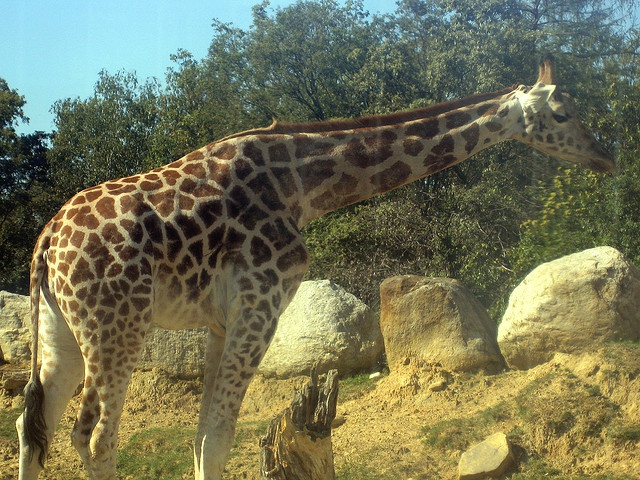Describe the objects in this image and their specific colors. I can see a giraffe in lightblue, gray, and black tones in this image. 